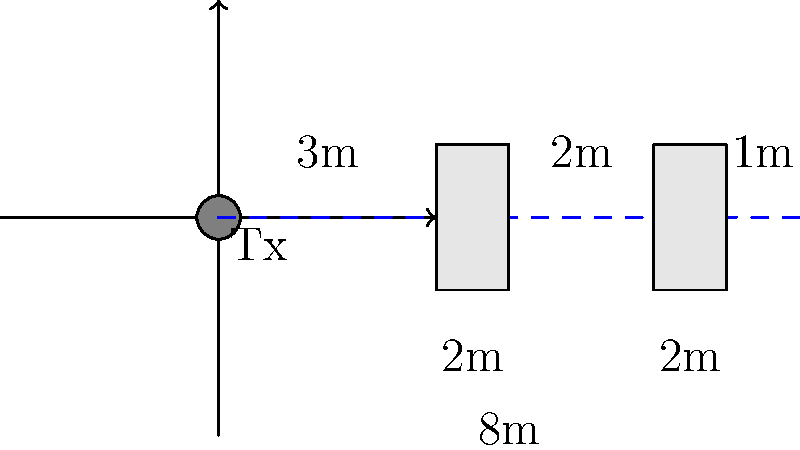You're setting up a live broadcast from a quirky location, and your signal needs to travel through two walls. The transmitter power is 100 mW, and you know that each meter of air causes a 20% signal loss, while each wall causes a 50% loss. If the total distance is 8 meters with walls at 3m and 6m from the transmitter, what's the final signal strength at the receiver? Don't forget to add a touch of your trademark humor! Alright, let's break this down step-by-step, with a sprinkle of broadcast veteran sass:

1) Initial power: 100 mW (milliwatts). That's enough to power a small LED, or your producer's brain on a Monday morning.

2) Signal loss through air:
   - 20% loss per meter
   - 8 meters total
   - Loss factor per meter: $0.8$ (because $100\% - 20\% = 80\% = 0.8$)
   - Total air loss factor: $0.8^8 = 0.1678$

3) Signal loss through walls:
   - 50% loss per wall
   - 2 walls
   - Loss factor per wall: $0.5$
   - Total wall loss factor: $0.5^2 = 0.25$

4) Calculate the final signal strength:

   $$\text{Final Power} = 100 \text{ mW} \times 0.1678 \times 0.25$$

5) Let's crunch those numbers:

   $$\text{Final Power} = 100 \times 0.1678 \times 0.25 = 4.195 \text{ mW}$$

6) Round to three decimal places:

   $$\text{Final Power} = 4.195 \text{ mW}$$

And there you have it! Your signal is now weaker than a comedian's punchline on open mic night.
Answer: 4.195 mW 